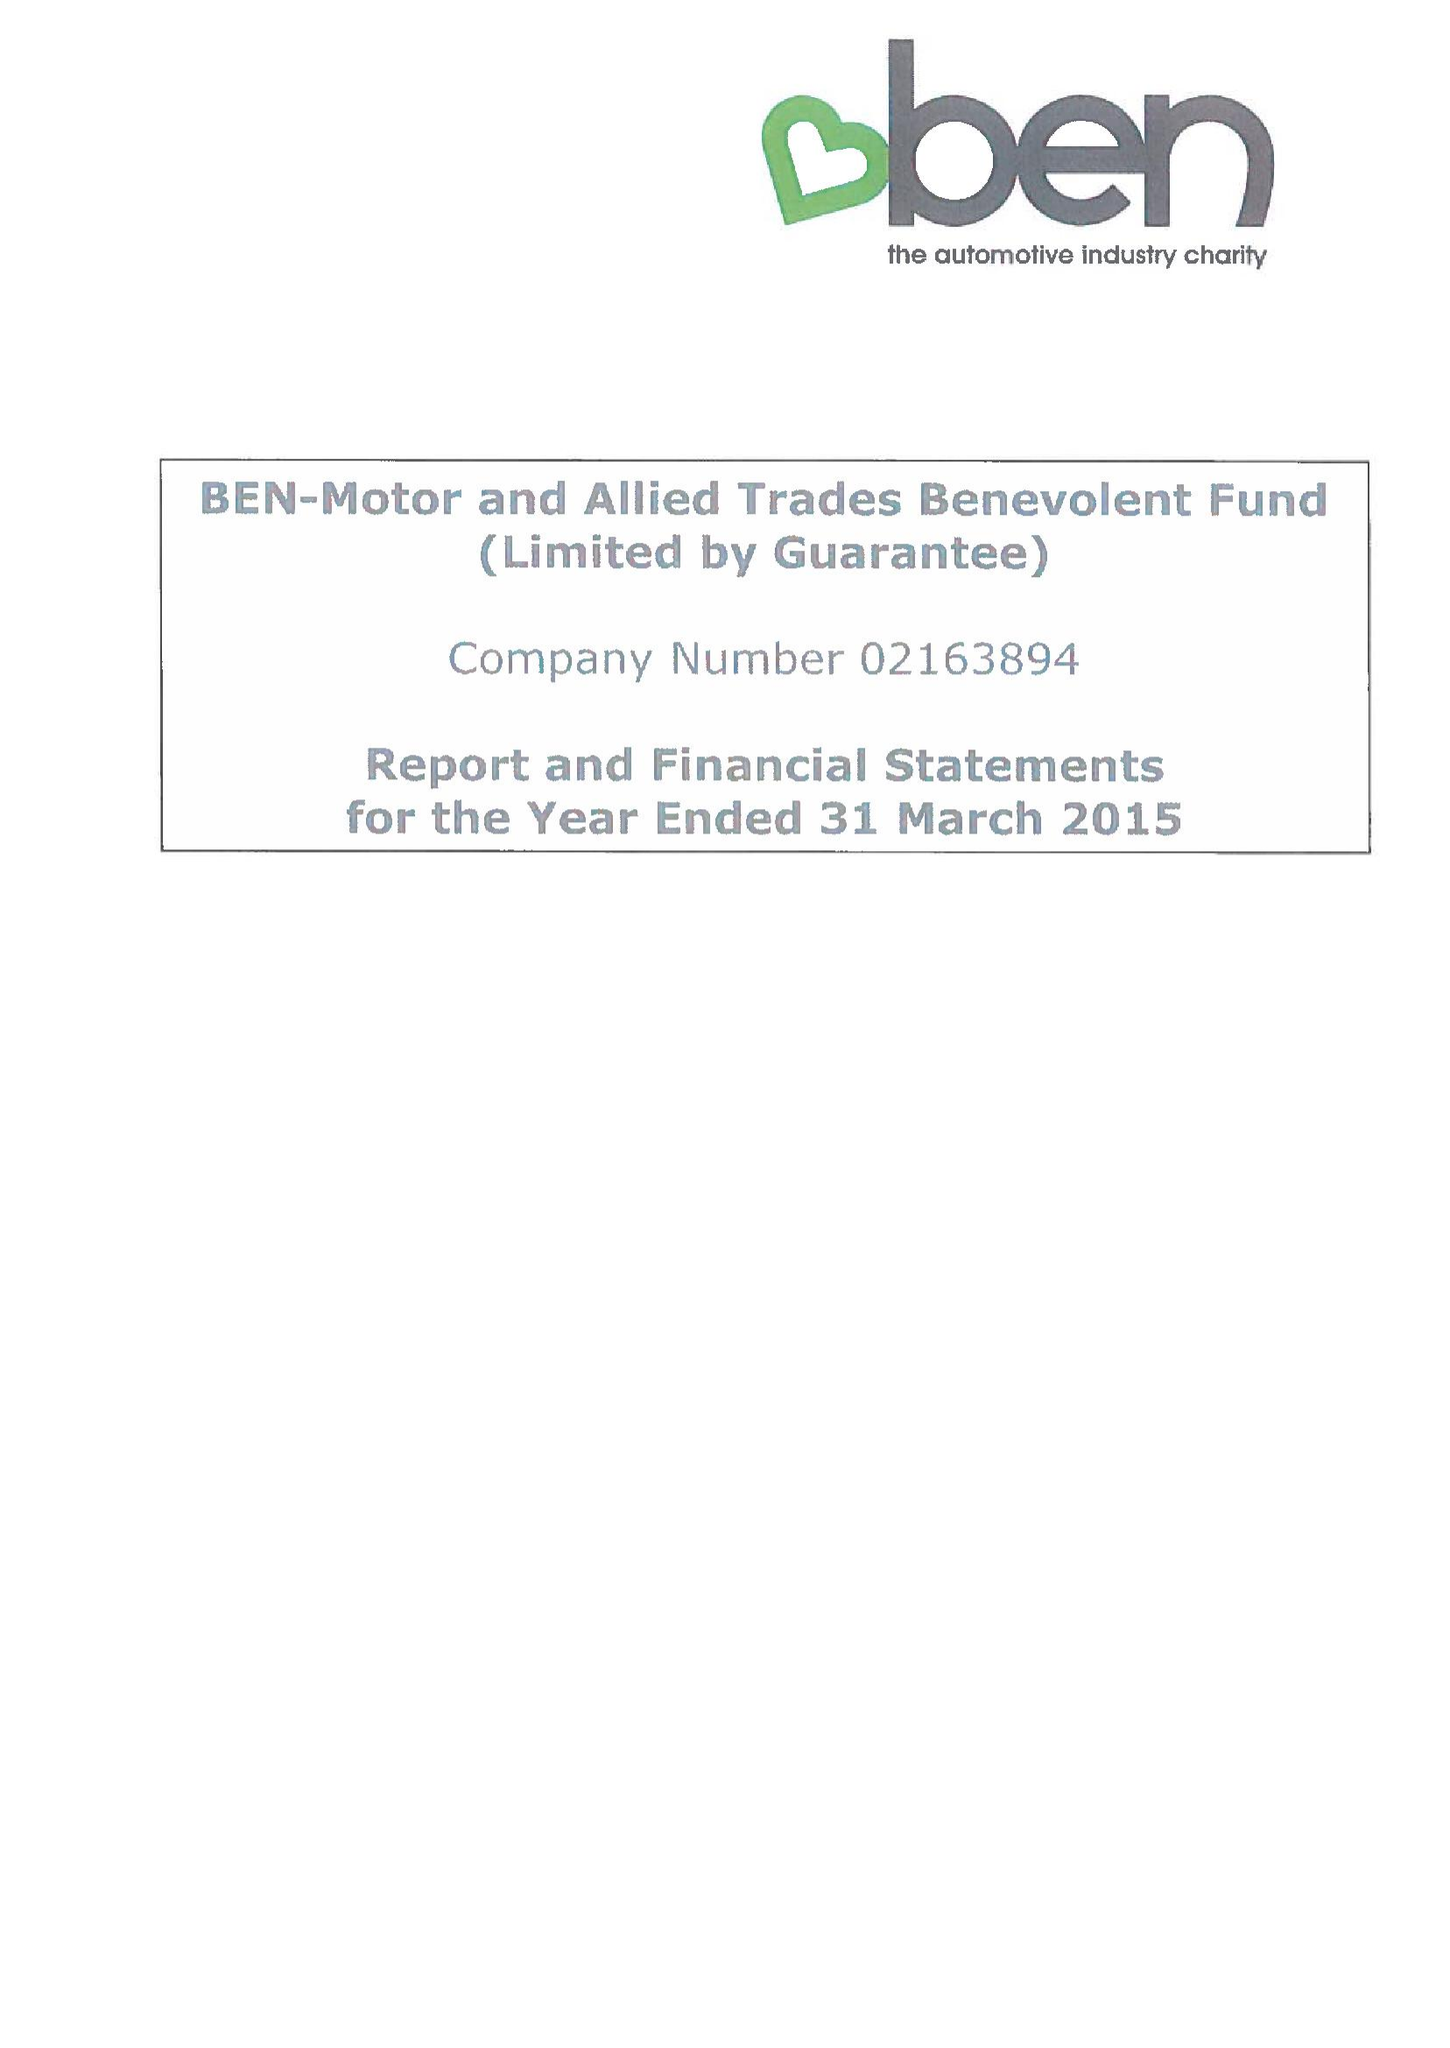What is the value for the charity_name?
Answer the question using a single word or phrase. Ben - Motor and Allied Trades Benevolent Fund 